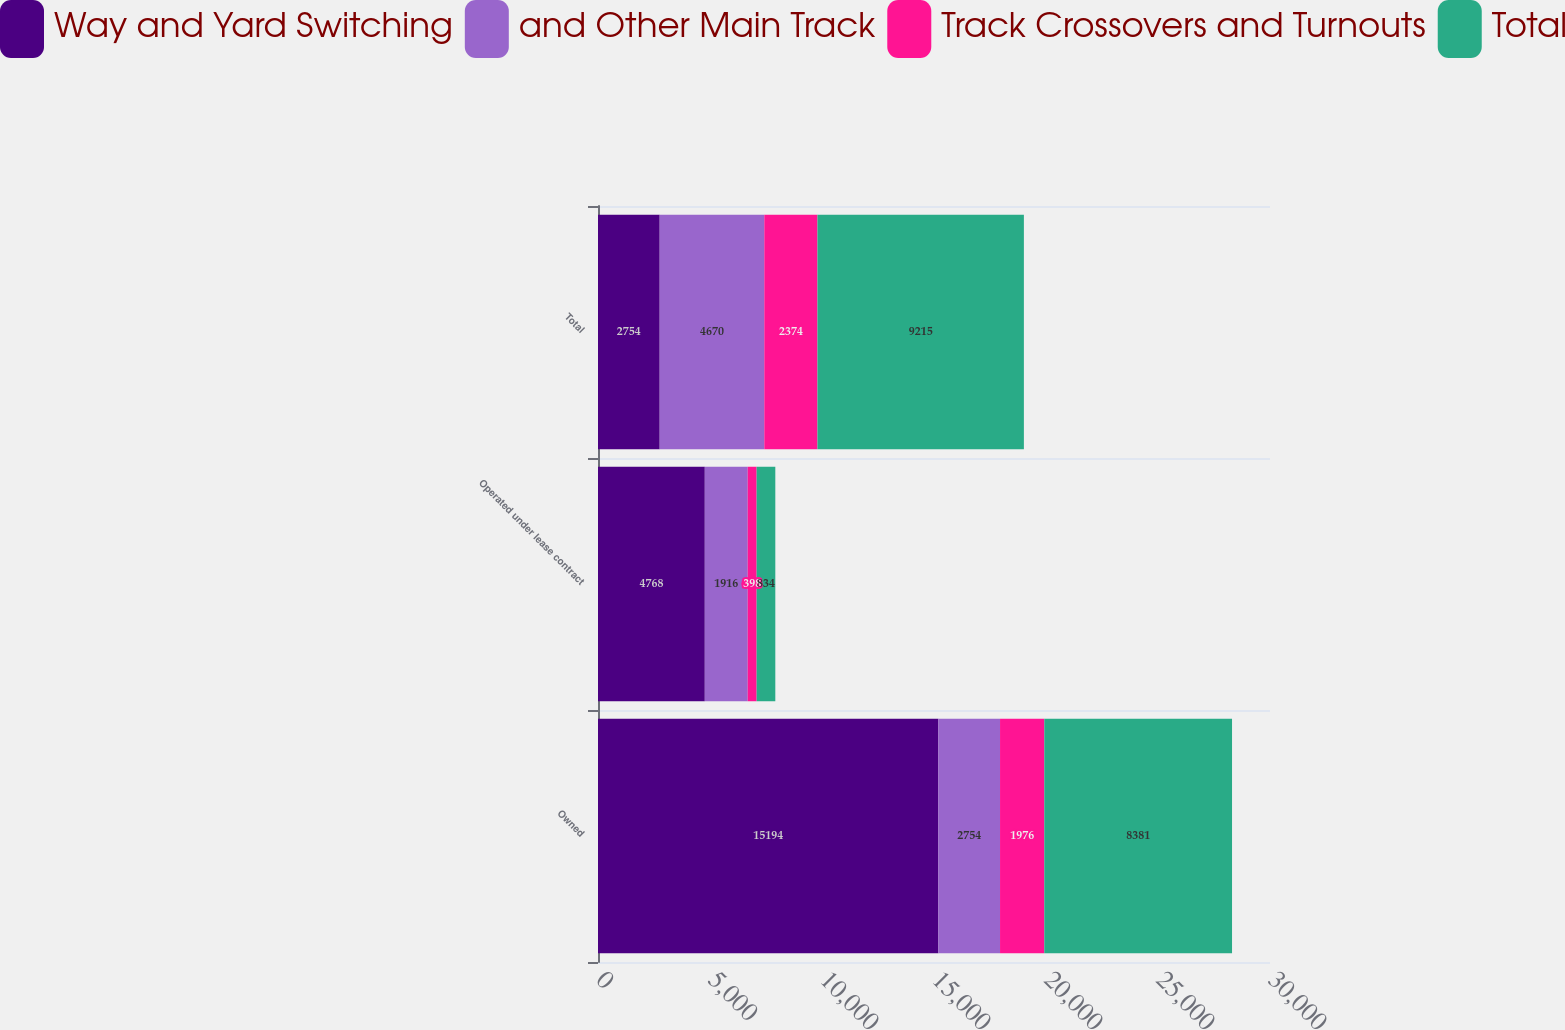Convert chart. <chart><loc_0><loc_0><loc_500><loc_500><stacked_bar_chart><ecel><fcel>Owned<fcel>Operated under lease contract<fcel>Total<nl><fcel>Way and Yard Switching<fcel>15194<fcel>4768<fcel>2754<nl><fcel>and Other Main Track<fcel>2754<fcel>1916<fcel>4670<nl><fcel>Track Crossovers and Turnouts<fcel>1976<fcel>398<fcel>2374<nl><fcel>Total<fcel>8381<fcel>834<fcel>9215<nl></chart> 